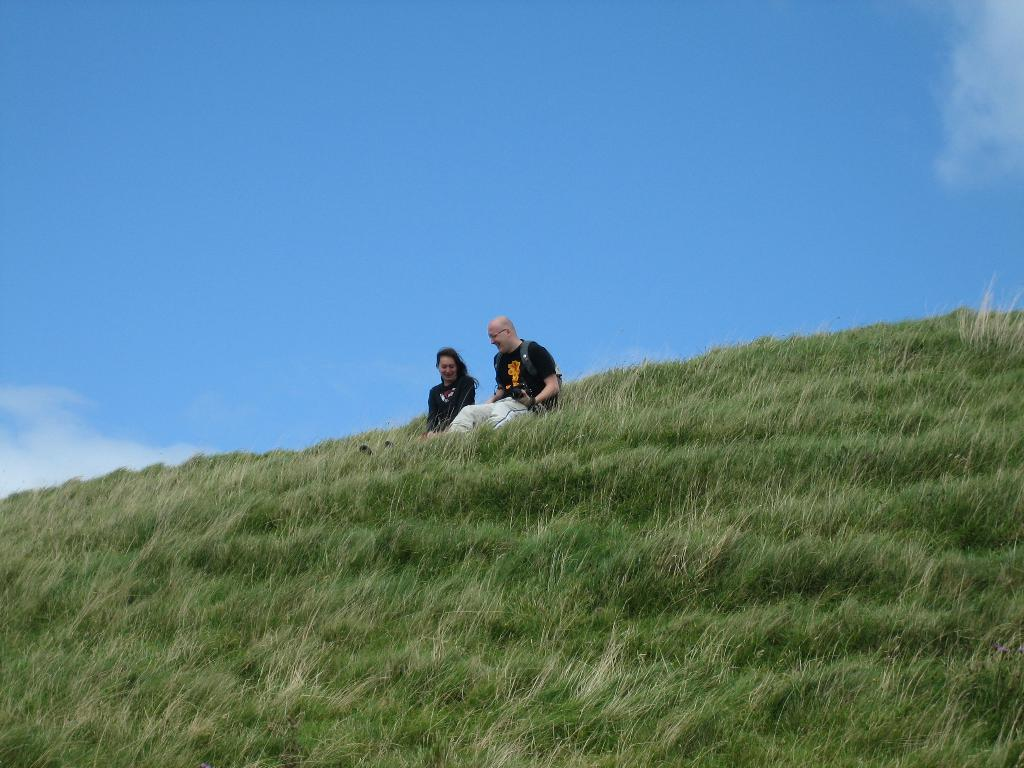What type of vegetation can be seen in the foreground of the image? There is grass in the foreground of the image. Who is present in the middle of the image? A lady is present in the middle of the image. What is the man in the middle of the image doing? A man is sitting on the grass in the middle of the image. What can be seen at the top of the image? The sky is visible at the top of the image. Can you tell me how many cans of stew are present in the image? There are no cans of stew present in the image. Is there an island visible in the image? There is no island visible in the image. 